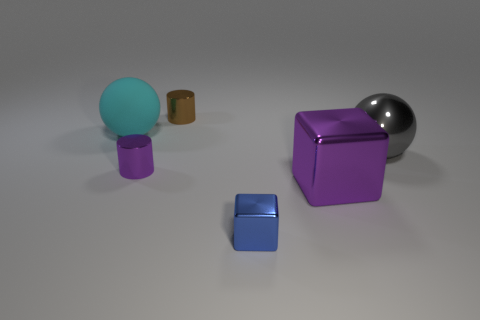Add 3 green metal objects. How many objects exist? 9 Subtract all cylinders. How many objects are left? 4 Subtract all purple blocks. Subtract all large metal cubes. How many objects are left? 4 Add 6 balls. How many balls are left? 8 Add 1 red shiny blocks. How many red shiny blocks exist? 1 Subtract 0 gray cubes. How many objects are left? 6 